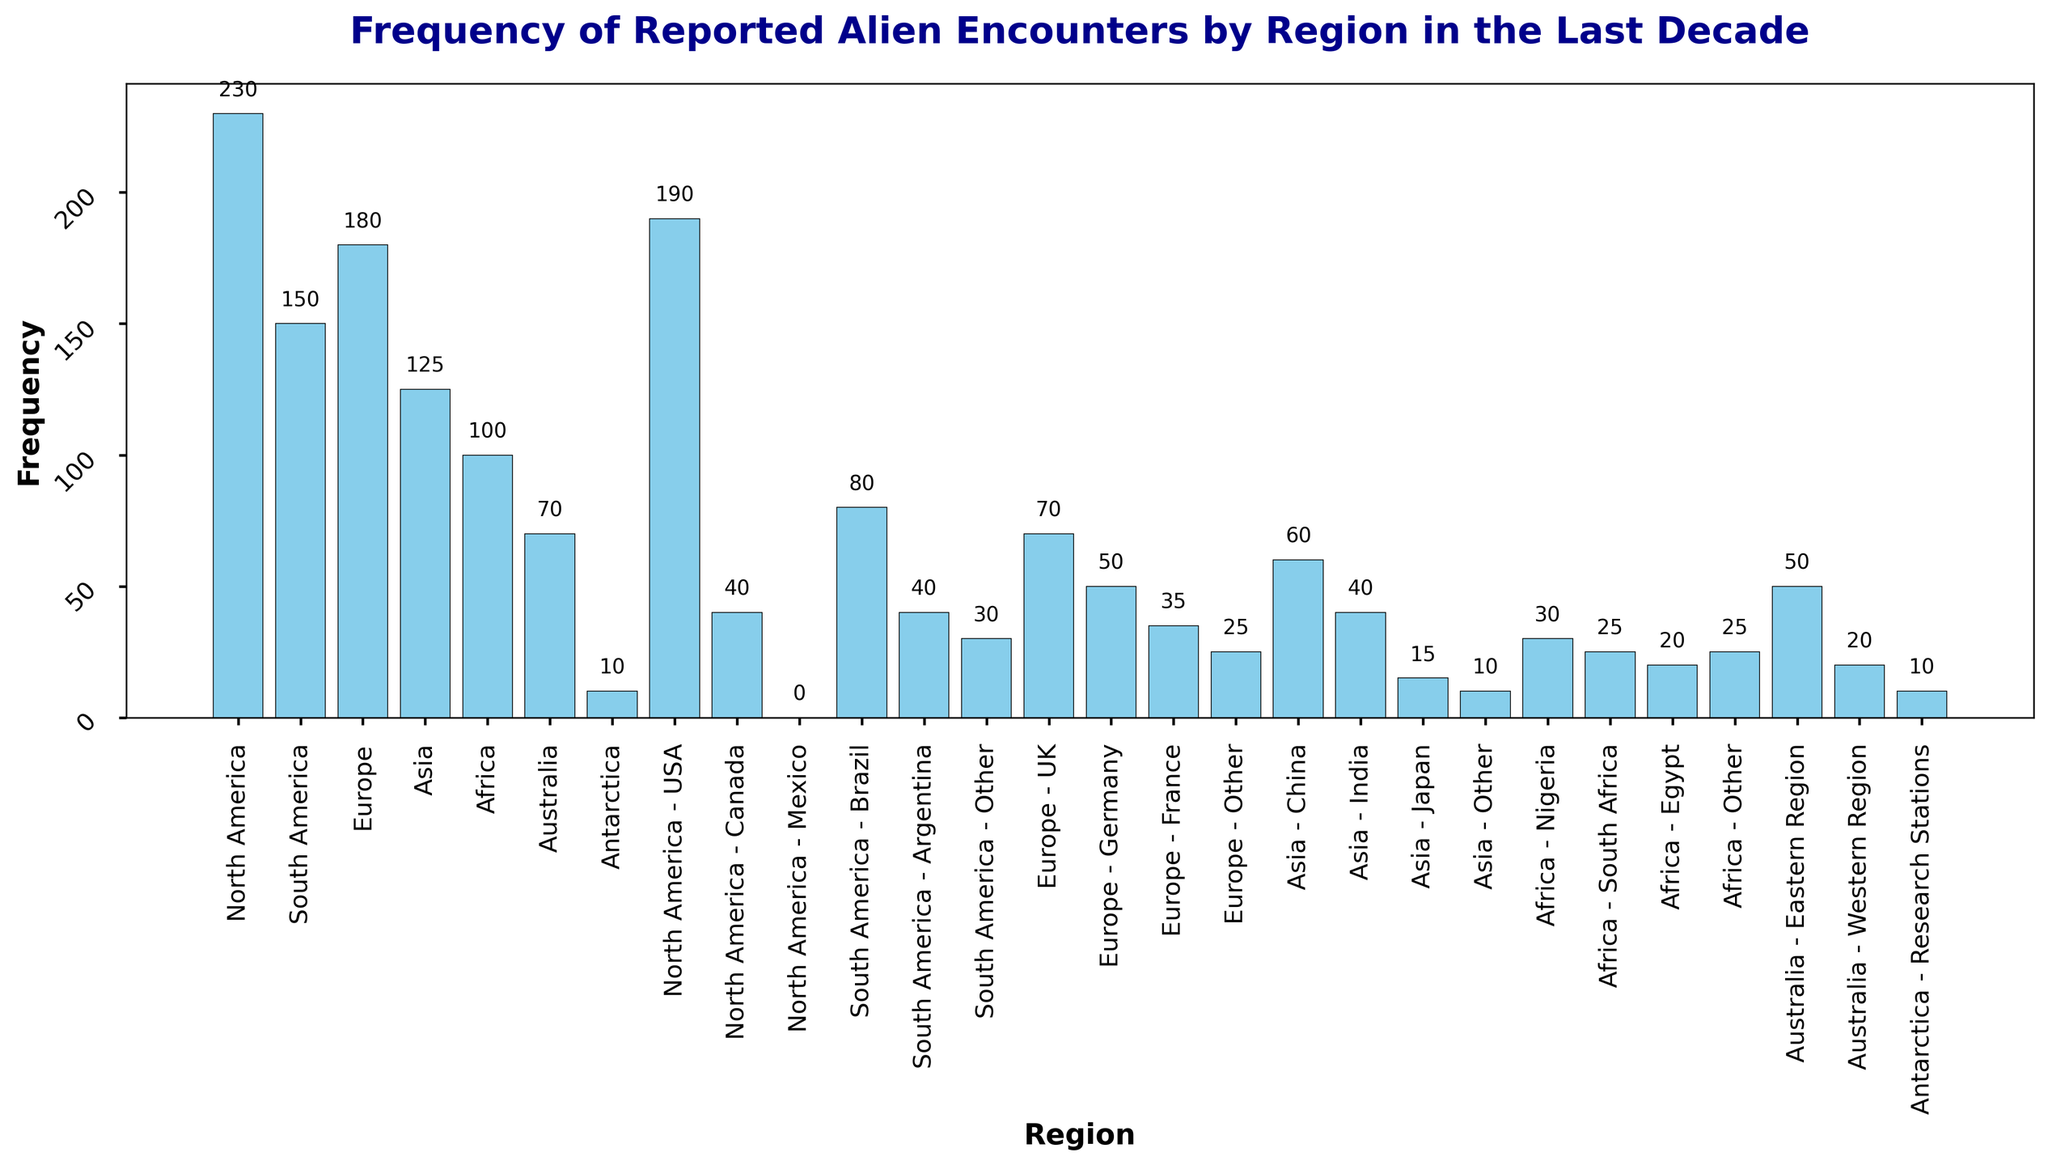Which region had the highest frequency of reported alien encounters in the last decade? To determine the region with the highest frequency, look for the tallest bar in the graph. The highest bar represents North America with a frequency of 230.
Answer: North America Which specific country in North America had the highest frequency of reported alien encounters? Examine the breakdown of frequencies within North America. The bar for North America - USA is taller than North America - Canada and North America - Mexico, indicating the highest frequency.
Answer: USA What is the combined total of reported alien encounters in South America and Europe? Add the frequencies of South America (150) and Europe (180) from the bar chart. 150 + 180 = 330.
Answer: 330 How does the frequency of reported alien encounters in Asia compare to that in Africa? Compare the heights of the bars for Asia (125) and Africa (100). Asia has a higher frequency of encounters than Africa.
Answer: Asia has a higher frequency What is the average frequency of reported alien encounters in the regions outside of North America, Europe, and South America? Sum the frequencies of Asia (125), Africa (100), Australia (70), and Antarctica (10), then divide by the number of regions (4). (125 + 100 + 70 + 10) / 4 = 305 / 4 = 76.25.
Answer: 76.25 Which two countries in South America have the closest frequency of reported alien encounters? Compare the frequencies of Brazil (80), Argentina (40), and Other (30). Argentina (40) and Other (30) have the closest frequencies.
Answer: Argentina and South America - Other By how much does the frequency of reported alien encounters in North America exceed that in Australia? Subtract the frequency for Australia (70) from the frequency for North America (230). 230 - 70 = 160.
Answer: 160 Which region had the least frequency of reported alien encounters and what is the frequency? Identify the shortest bar in the chart. Antarctica has the least frequency with a value of 10.
Answer: Antarctica, 10 How many more encounters were reported in North America than South America, Europe, and Asia combined? First, find the combined frequency of South America (150), Europe (180), and Asia (125). 150 + 180 + 125 = 455. Then, subtract this total from North America's frequency (230). 230 - 455 = -225. This shows that the combined total is actually higher than North America's total. Since we are asked how many more encounters North America has, the answer would involve the difference being negative, but we should state the result sensibly.
Answer: North America reported 225 fewer encounters than the combined total 